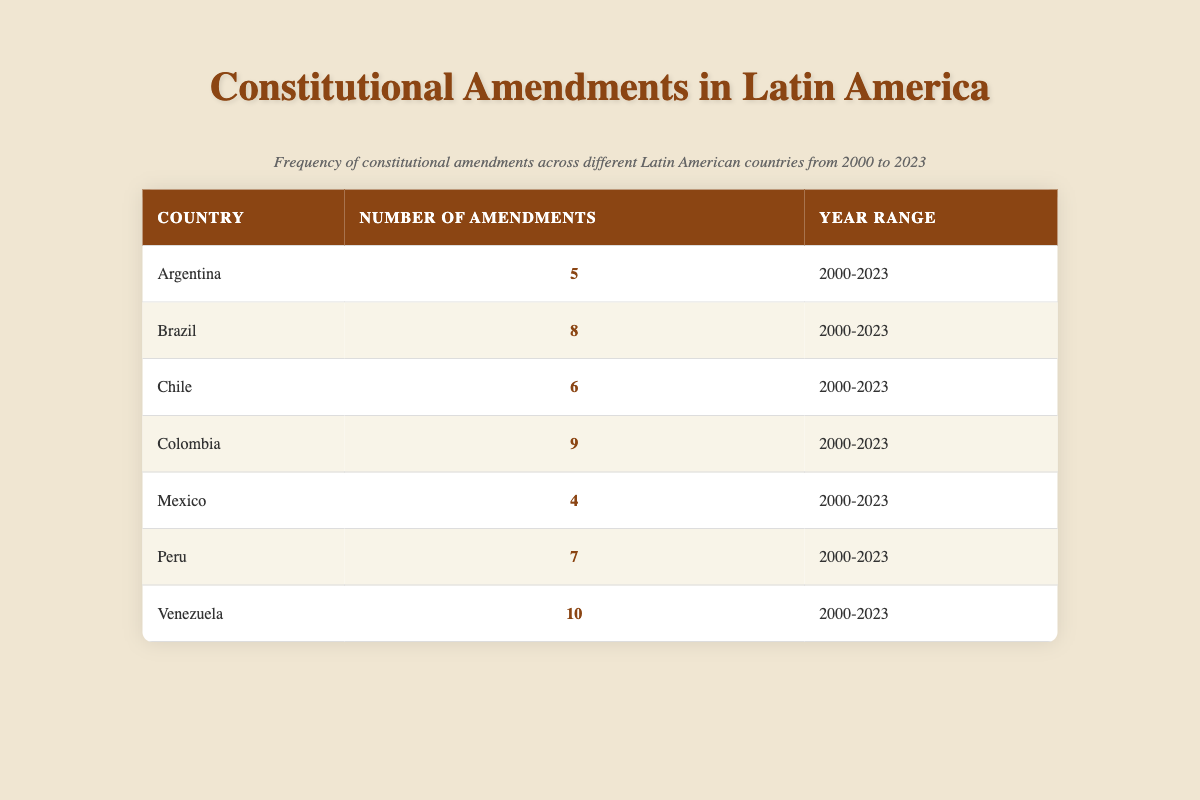What is the total number of constitutional amendments made in Argentina? According to the table, Argentina has made 5 constitutional amendments from 2000 to 2023.
Answer: 5 Which country made the least number of amendments? By examining the table, we see that Mexico has made the least number of amendments, with a total of 4.
Answer: Mexico How many countries made more than 6 amendments? The countries with more than 6 amendments are Brazil (8), Colombia (9), Peru (7), and Venezuela (10). That totals 4 countries.
Answer: 4 What is the average number of amendments across the countries listed? To find the average, we sum the number of amendments (5 + 8 + 6 + 9 + 4 + 7 + 10 = 49) and divide by the number of countries (7). Thus, the average is 49/7 = 7.
Answer: 7 Is it true that Brazil made more amendments than Peru? From the table, Brazil has 8 amendments and Peru has 7. Since 8 is greater than 7, the statement is true.
Answer: Yes Which country has the highest number of amendments and what is that number? The table shows that Venezuela has the highest number of amendments, with a total of 10.
Answer: Venezuela, 10 What is the difference in the number of amendments between Colombia and Argentina? Colombia has 9 amendments and Argentina has 5. The difference is calculated as 9 - 5 = 4 amendments.
Answer: 4 Which two countries have a combined total of amendments that is equal to or exceeds 15? Brazil (8) and Venezuela (10) together exceed 15, as their total is 18. Colombia (9) and Peru (7) also exceed it with a total of 16. Therefore, the answer is Brazil and Venezuela, or Colombia and Peru.
Answer: Brazil and Venezuela; Colombia and Peru 